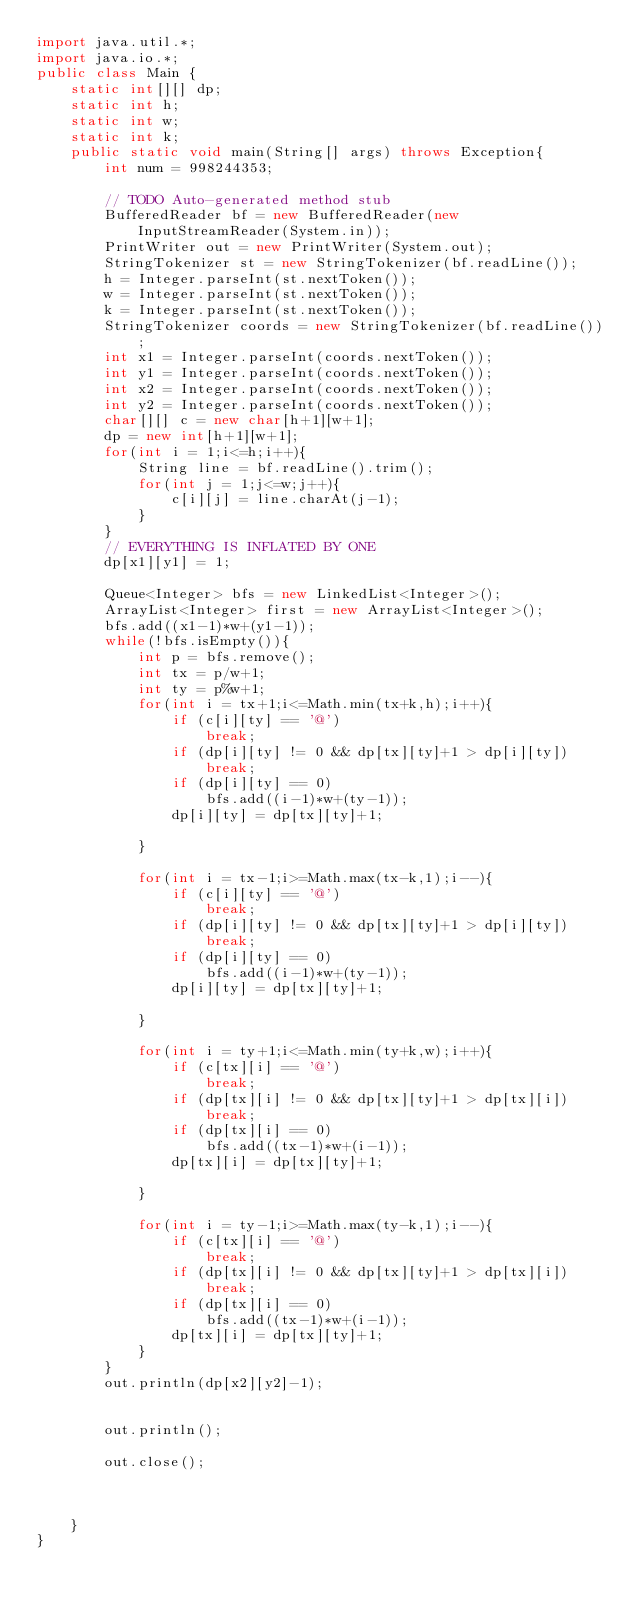Convert code to text. <code><loc_0><loc_0><loc_500><loc_500><_Java_>import java.util.*;
import java.io.*;
public class Main {
	static int[][] dp;
	static int h;
	static int w;
	static int k;
	public static void main(String[] args) throws Exception{
		int num = 998244353;
 
		// TODO Auto-generated method stub
 		BufferedReader bf = new BufferedReader(new InputStreamReader(System.in));
 		PrintWriter out = new PrintWriter(System.out);
 		StringTokenizer st = new StringTokenizer(bf.readLine());
 		h = Integer.parseInt(st.nextToken());
 		w = Integer.parseInt(st.nextToken());
 		k = Integer.parseInt(st.nextToken());
 		StringTokenizer coords = new StringTokenizer(bf.readLine());
 		int x1 = Integer.parseInt(coords.nextToken());
 		int y1 = Integer.parseInt(coords.nextToken());
 		int x2 = Integer.parseInt(coords.nextToken());
 		int y2 = Integer.parseInt(coords.nextToken());
 		char[][] c = new char[h+1][w+1];
 		dp = new int[h+1][w+1];
 		for(int i = 1;i<=h;i++){
 			String line = bf.readLine().trim();
 			for(int j = 1;j<=w;j++){
 				c[i][j] = line.charAt(j-1);
 			}
 		}
 		// EVERYTHING IS INFLATED BY ONE
 		dp[x1][y1] = 1;
 		
 		Queue<Integer> bfs = new LinkedList<Integer>();
 		ArrayList<Integer> first = new ArrayList<Integer>();
 		bfs.add((x1-1)*w+(y1-1));
 		while(!bfs.isEmpty()){
 			int p = bfs.remove();
 			int tx = p/w+1;
 			int ty = p%w+1;
 			for(int i = tx+1;i<=Math.min(tx+k,h);i++){
 				if (c[i][ty] == '@')
 					break;
 				if (dp[i][ty] != 0 && dp[tx][ty]+1 > dp[i][ty])
 					break;
 				if (dp[i][ty] == 0)
 					bfs.add((i-1)*w+(ty-1));
 				dp[i][ty] = dp[tx][ty]+1;
 				
 			}
 			
 			for(int i = tx-1;i>=Math.max(tx-k,1);i--){
 				if (c[i][ty] == '@')
 					break;
 				if (dp[i][ty] != 0 && dp[tx][ty]+1 > dp[i][ty])
 					break;
 				if (dp[i][ty] == 0)
 					bfs.add((i-1)*w+(ty-1));
 				dp[i][ty] = dp[tx][ty]+1;
 
 			}
 			
 			for(int i = ty+1;i<=Math.min(ty+k,w);i++){
 				if (c[tx][i] == '@')
 					break;
 				if (dp[tx][i] != 0 && dp[tx][ty]+1 > dp[tx][i])
 					break;
 				if (dp[tx][i] == 0)
 					bfs.add((tx-1)*w+(i-1));
 				dp[tx][i] = dp[tx][ty]+1;
 				
 			}
 			
 			for(int i = ty-1;i>=Math.max(ty-k,1);i--){
 				if (c[tx][i] == '@')
 					break;
 				if (dp[tx][i] != 0 && dp[tx][ty]+1 > dp[tx][i])
 					break;
 				if (dp[tx][i] == 0)
 					bfs.add((tx-1)*w+(i-1));
 				dp[tx][i] = dp[tx][ty]+1;
 			}
 		}
 		out.println(dp[x2][y2]-1);
 		
 		
 		out.println();
	 		
 		out.close();
 		
 		
 		
 	}
}</code> 